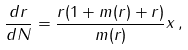<formula> <loc_0><loc_0><loc_500><loc_500>\frac { d r } { d N } = \frac { r ( 1 + m ( r ) + r ) } { m ( r ) } x \, ,</formula> 